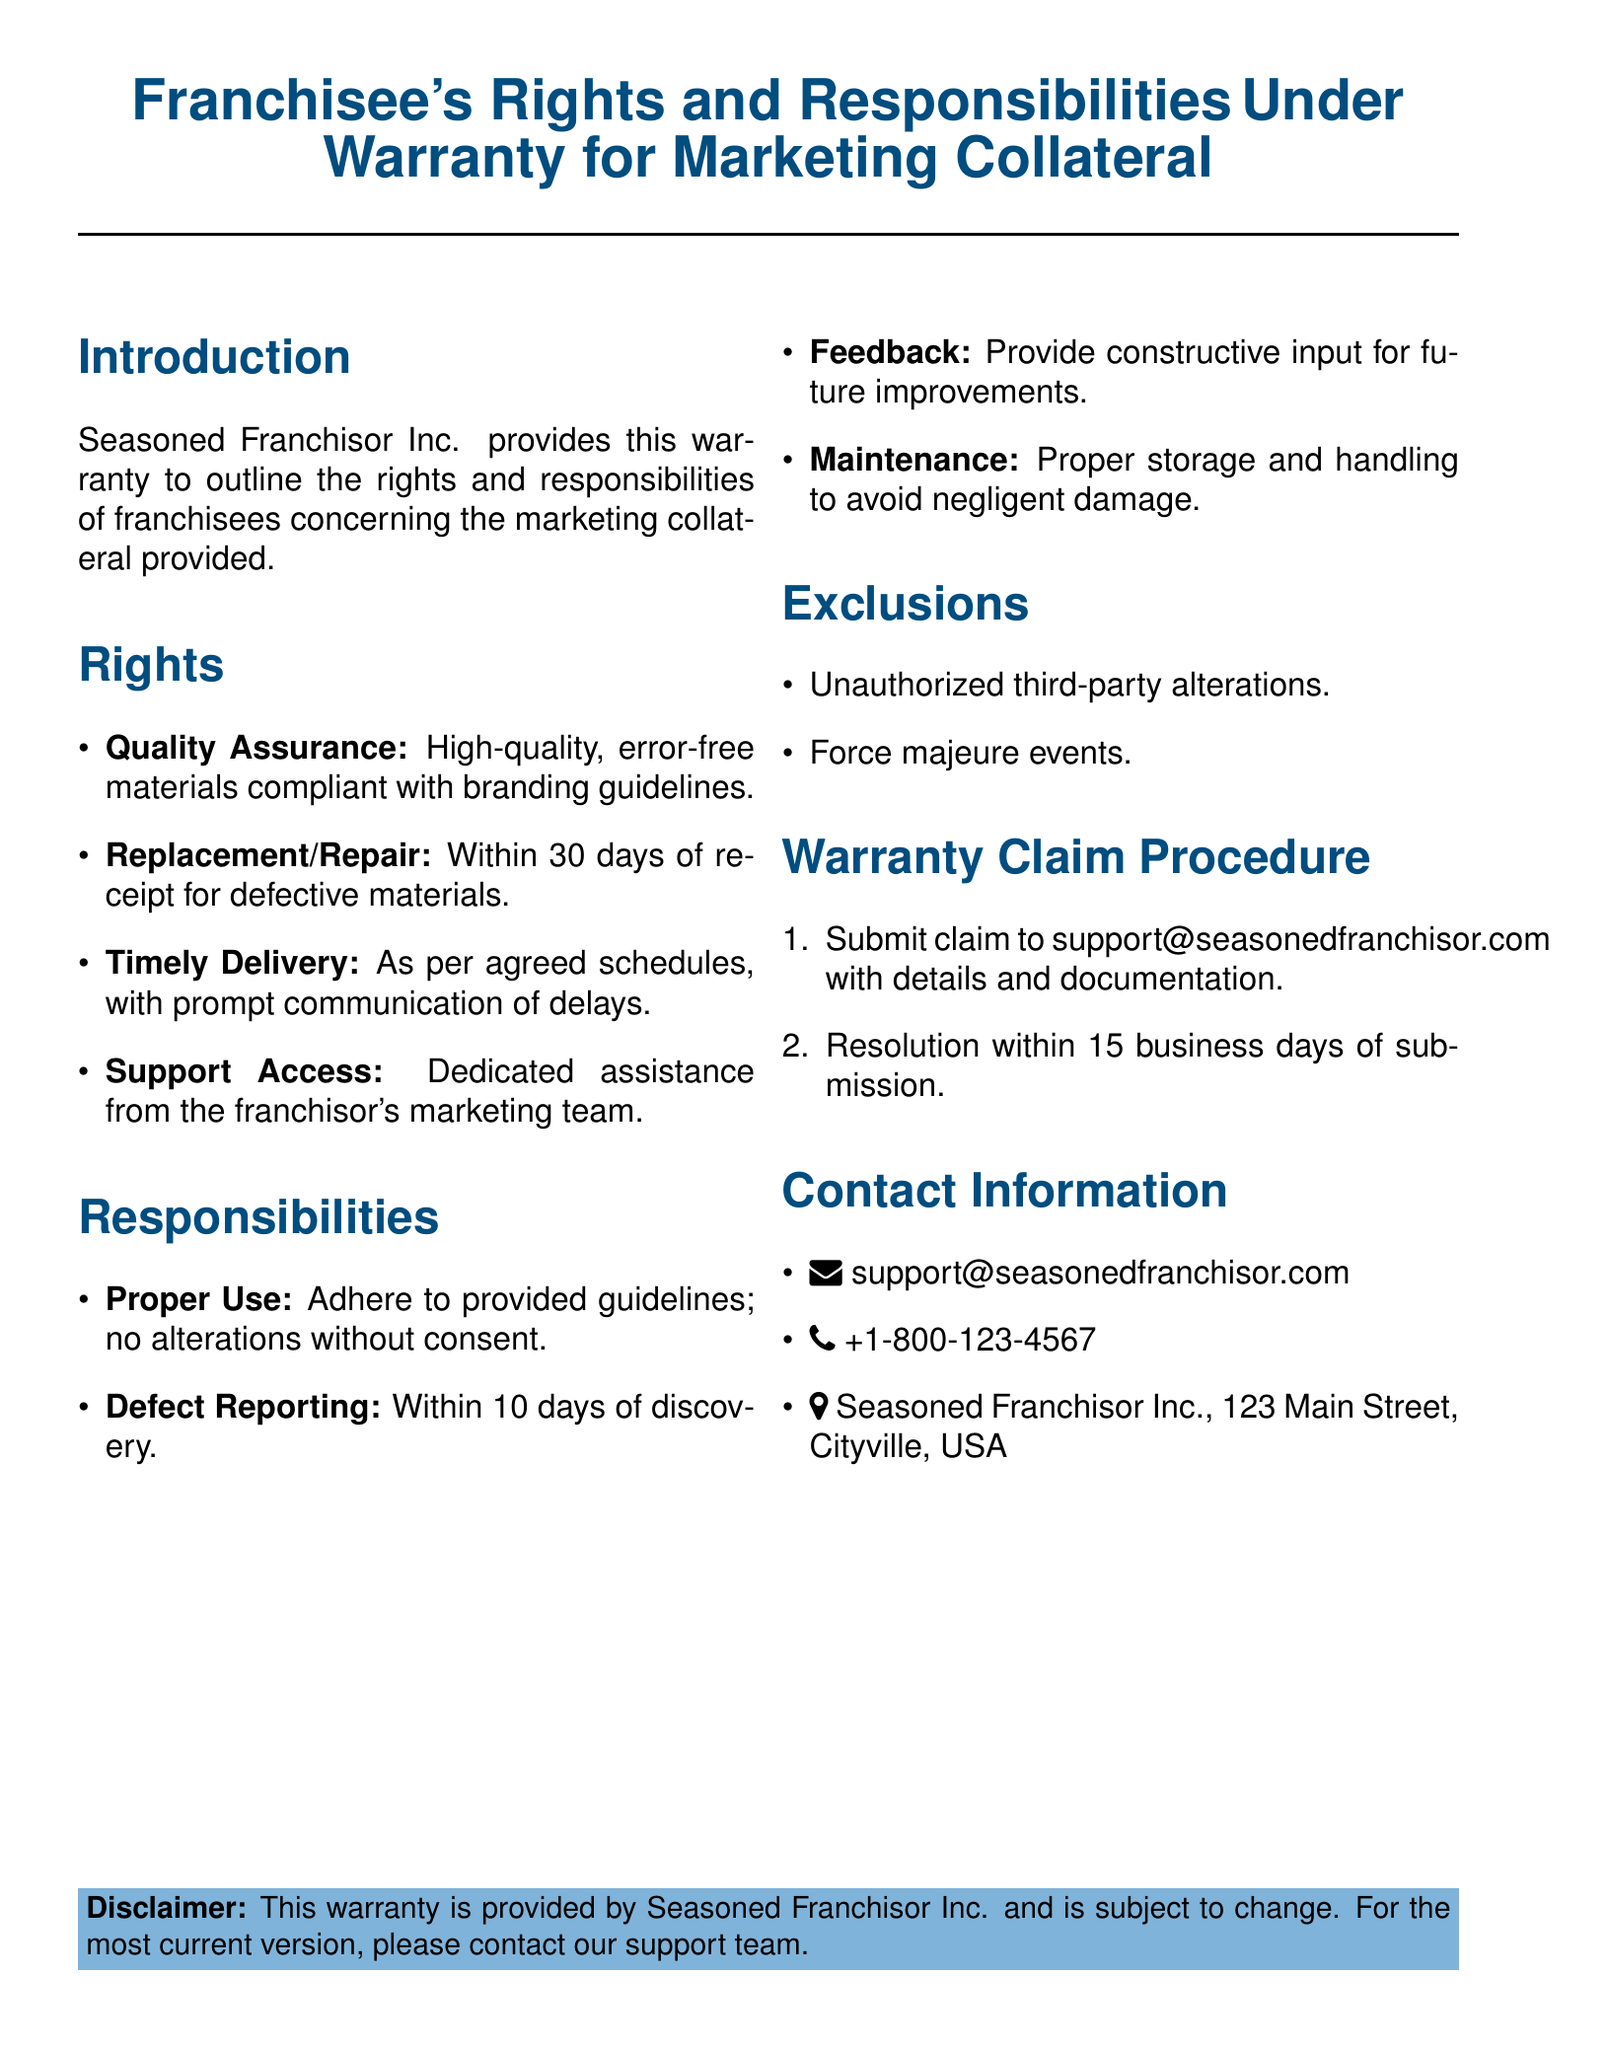What company provides this warranty? The document states that the warranty is provided by Seasoned Franchisor Inc.
Answer: Seasoned Franchisor Inc What must franchisees report within 10 days? The responsibilities section specifies that defects must be reported within 10 days of discovery.
Answer: Defects What is the time frame for replacing defective materials? The warranty mentions that franchisees can request replacement or repair within 30 days of receipt for defective materials.
Answer: 30 days How many business days does the franchisor have to resolve a warranty claim? The warranty claim procedure indicates that resolution will occur within 15 business days of submission.
Answer: 15 business days What kind of materials should franchisees receive? The rights section highlights that franchisees are entitled to high-quality, error-free materials compliant with branding guidelines.
Answer: High-quality, error-free materials What should franchisees do with constructive input? The responsibilities section indicates that franchisees should provide feedback for future improvements.
Answer: Provide feedback What type of events are excluded from the warranty? The exclusions section lists unauthorized third-party alterations and force majeure events as exclusions.
Answer: Unauthorized third-party alterations, force majeure events What is the email address for submitting claims? The contact information states the email address for submitting claims is support@seasonedfranchisor.com.
Answer: support@seasonedfranchisor.com 